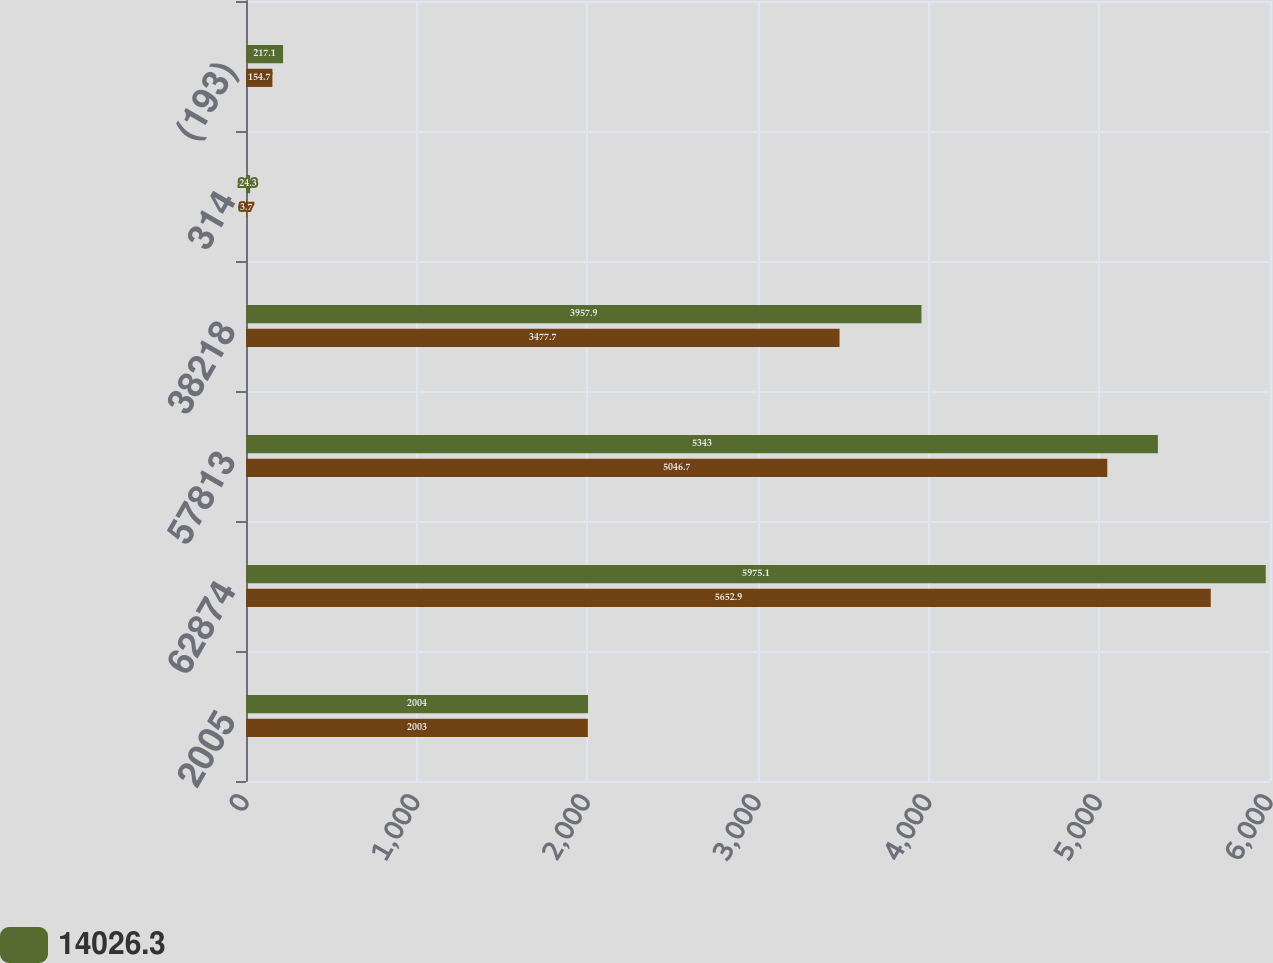Convert chart. <chart><loc_0><loc_0><loc_500><loc_500><stacked_bar_chart><ecel><fcel>2005<fcel>62874<fcel>57813<fcel>38218<fcel>314<fcel>(193)<nl><fcel>14026.3<fcel>2004<fcel>5975.1<fcel>5343<fcel>3957.9<fcel>24.3<fcel>217.1<nl><fcel>nan<fcel>2003<fcel>5652.9<fcel>5046.7<fcel>3477.7<fcel>3.7<fcel>154.7<nl></chart> 